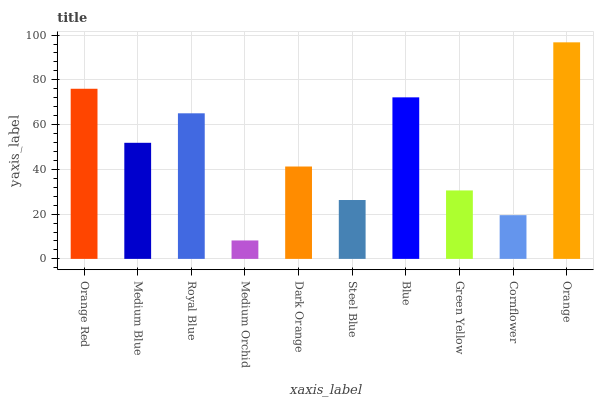Is Medium Orchid the minimum?
Answer yes or no. Yes. Is Orange the maximum?
Answer yes or no. Yes. Is Medium Blue the minimum?
Answer yes or no. No. Is Medium Blue the maximum?
Answer yes or no. No. Is Orange Red greater than Medium Blue?
Answer yes or no. Yes. Is Medium Blue less than Orange Red?
Answer yes or no. Yes. Is Medium Blue greater than Orange Red?
Answer yes or no. No. Is Orange Red less than Medium Blue?
Answer yes or no. No. Is Medium Blue the high median?
Answer yes or no. Yes. Is Dark Orange the low median?
Answer yes or no. Yes. Is Steel Blue the high median?
Answer yes or no. No. Is Medium Orchid the low median?
Answer yes or no. No. 